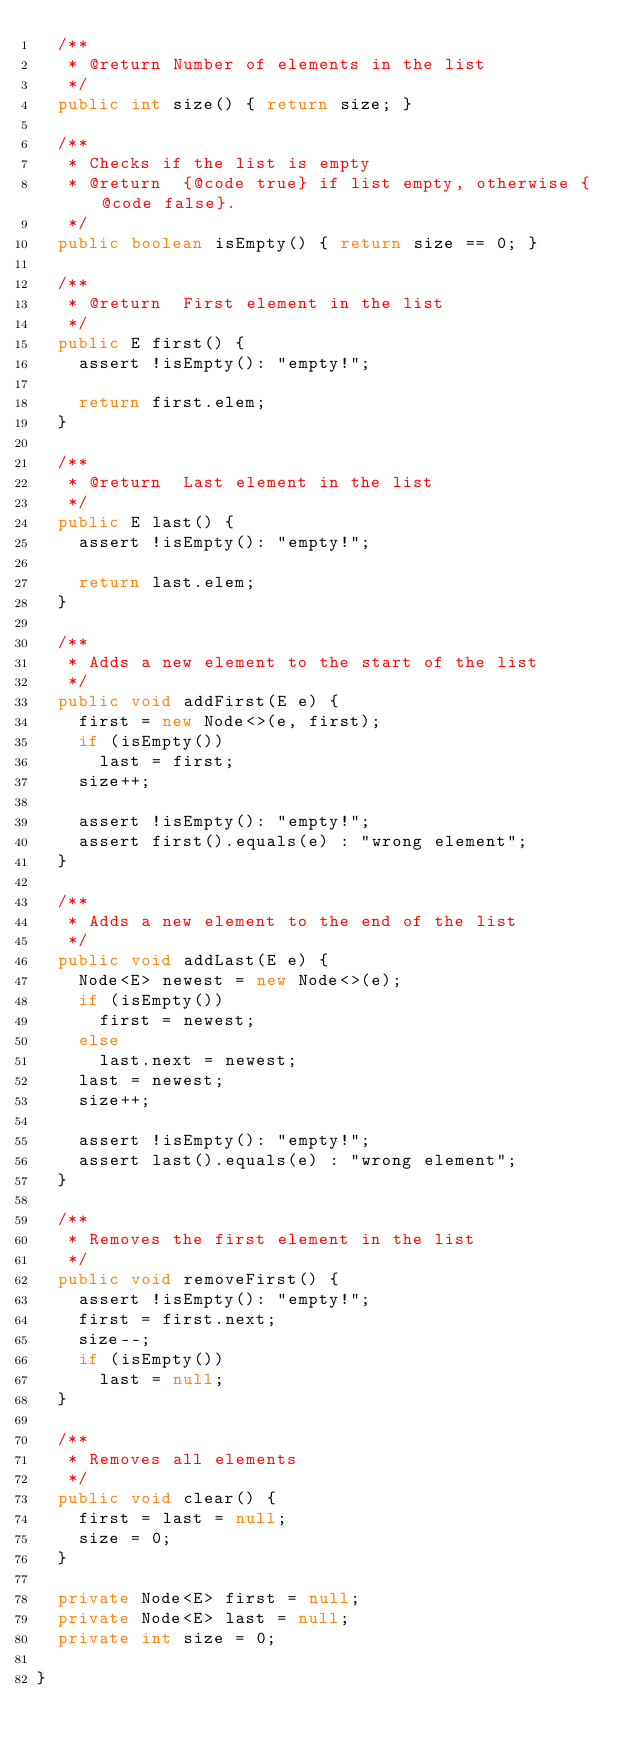Convert code to text. <code><loc_0><loc_0><loc_500><loc_500><_Java_>  /**
   * @return Number of elements in the list
   */
  public int size() { return size; }

  /**
   * Checks if the list is empty
   * @return  {@code true} if list empty, otherwise {@code false}.
   */
  public boolean isEmpty() { return size == 0; }

  /**
   * @return  First element in the list
   */
  public E first() {
    assert !isEmpty(): "empty!";

    return first.elem;
  }

  /**
   * @return  Last element in the list
   */
  public E last() {
    assert !isEmpty(): "empty!";

    return last.elem;
  }

  /**
   * Adds a new element to the start of the list
   */
  public void addFirst(E e) {
    first = new Node<>(e, first);
    if (isEmpty())
      last = first;
    size++;

    assert !isEmpty(): "empty!";
    assert first().equals(e) : "wrong element";
  }

  /**
   * Adds a new element to the end of the list
   */
  public void addLast(E e) {
    Node<E> newest = new Node<>(e);
    if (isEmpty())
      first = newest;
    else
      last.next = newest;
    last = newest;
    size++;

    assert !isEmpty(): "empty!";
    assert last().equals(e) : "wrong element";
  }

  /**
   * Removes the first element in the list
   */
  public void removeFirst() {
    assert !isEmpty(): "empty!";
    first = first.next;
    size--;
    if (isEmpty())
      last = null;
  }

  /**
   * Removes all elements
   */
  public void clear() {
    first = last = null;
    size = 0;
  }

  private Node<E> first = null;
  private Node<E> last = null;
  private int size = 0;

}


</code> 